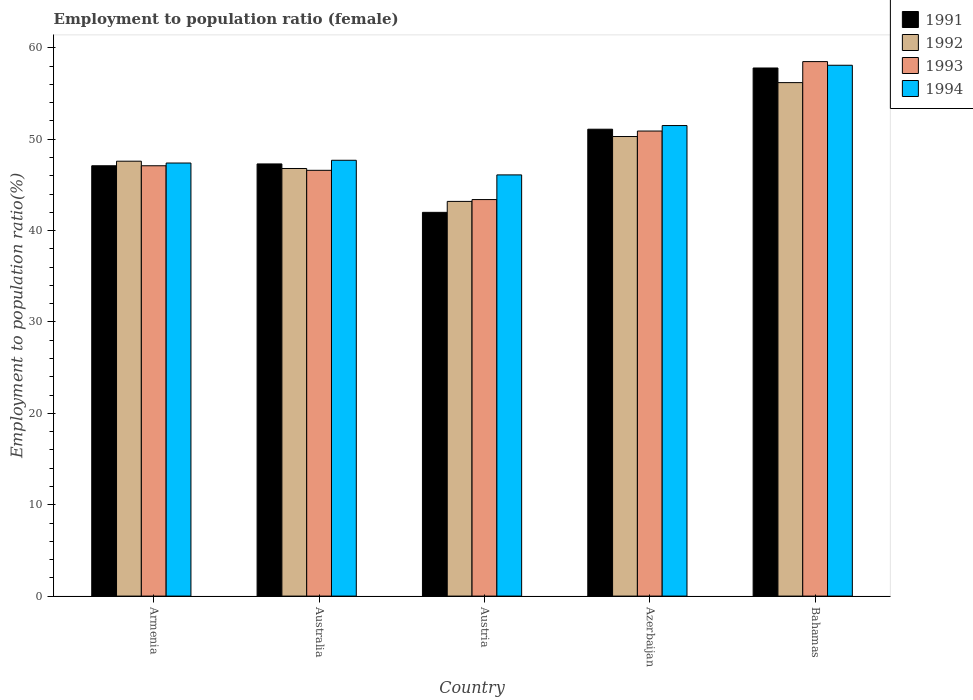How many groups of bars are there?
Provide a succinct answer. 5. How many bars are there on the 2nd tick from the left?
Your answer should be very brief. 4. How many bars are there on the 2nd tick from the right?
Offer a very short reply. 4. What is the label of the 2nd group of bars from the left?
Make the answer very short. Australia. What is the employment to population ratio in 1993 in Australia?
Give a very brief answer. 46.6. Across all countries, what is the maximum employment to population ratio in 1994?
Provide a succinct answer. 58.1. Across all countries, what is the minimum employment to population ratio in 1992?
Your response must be concise. 43.2. In which country was the employment to population ratio in 1992 maximum?
Make the answer very short. Bahamas. In which country was the employment to population ratio in 1994 minimum?
Give a very brief answer. Austria. What is the total employment to population ratio in 1994 in the graph?
Give a very brief answer. 250.8. What is the difference between the employment to population ratio in 1992 in Armenia and that in Azerbaijan?
Offer a terse response. -2.7. What is the difference between the employment to population ratio in 1991 in Armenia and the employment to population ratio in 1994 in Azerbaijan?
Give a very brief answer. -4.4. What is the average employment to population ratio in 1992 per country?
Keep it short and to the point. 48.82. What is the difference between the employment to population ratio of/in 1991 and employment to population ratio of/in 1994 in Azerbaijan?
Offer a terse response. -0.4. In how many countries, is the employment to population ratio in 1991 greater than 4 %?
Provide a short and direct response. 5. What is the ratio of the employment to population ratio in 1991 in Azerbaijan to that in Bahamas?
Provide a succinct answer. 0.88. Is the employment to population ratio in 1993 in Austria less than that in Azerbaijan?
Provide a succinct answer. Yes. Is the difference between the employment to population ratio in 1991 in Armenia and Austria greater than the difference between the employment to population ratio in 1994 in Armenia and Austria?
Offer a very short reply. Yes. What is the difference between the highest and the second highest employment to population ratio in 1993?
Offer a terse response. 7.6. What is the difference between the highest and the lowest employment to population ratio in 1992?
Your answer should be compact. 13. Is it the case that in every country, the sum of the employment to population ratio in 1992 and employment to population ratio in 1994 is greater than the sum of employment to population ratio in 1991 and employment to population ratio in 1993?
Offer a terse response. No. What does the 2nd bar from the left in Azerbaijan represents?
Provide a succinct answer. 1992. What does the 3rd bar from the right in Austria represents?
Your answer should be very brief. 1992. How many bars are there?
Your response must be concise. 20. Are all the bars in the graph horizontal?
Provide a succinct answer. No. How many countries are there in the graph?
Ensure brevity in your answer.  5. Does the graph contain grids?
Ensure brevity in your answer.  No. How many legend labels are there?
Ensure brevity in your answer.  4. How are the legend labels stacked?
Your answer should be compact. Vertical. What is the title of the graph?
Ensure brevity in your answer.  Employment to population ratio (female). Does "1969" appear as one of the legend labels in the graph?
Offer a terse response. No. What is the label or title of the Y-axis?
Your answer should be compact. Employment to population ratio(%). What is the Employment to population ratio(%) of 1991 in Armenia?
Your answer should be compact. 47.1. What is the Employment to population ratio(%) in 1992 in Armenia?
Give a very brief answer. 47.6. What is the Employment to population ratio(%) in 1993 in Armenia?
Make the answer very short. 47.1. What is the Employment to population ratio(%) in 1994 in Armenia?
Provide a succinct answer. 47.4. What is the Employment to population ratio(%) of 1991 in Australia?
Give a very brief answer. 47.3. What is the Employment to population ratio(%) of 1992 in Australia?
Your answer should be very brief. 46.8. What is the Employment to population ratio(%) of 1993 in Australia?
Make the answer very short. 46.6. What is the Employment to population ratio(%) of 1994 in Australia?
Ensure brevity in your answer.  47.7. What is the Employment to population ratio(%) in 1991 in Austria?
Provide a short and direct response. 42. What is the Employment to population ratio(%) of 1992 in Austria?
Offer a terse response. 43.2. What is the Employment to population ratio(%) in 1993 in Austria?
Offer a very short reply. 43.4. What is the Employment to population ratio(%) of 1994 in Austria?
Offer a terse response. 46.1. What is the Employment to population ratio(%) in 1991 in Azerbaijan?
Offer a very short reply. 51.1. What is the Employment to population ratio(%) of 1992 in Azerbaijan?
Keep it short and to the point. 50.3. What is the Employment to population ratio(%) of 1993 in Azerbaijan?
Ensure brevity in your answer.  50.9. What is the Employment to population ratio(%) in 1994 in Azerbaijan?
Your response must be concise. 51.5. What is the Employment to population ratio(%) in 1991 in Bahamas?
Offer a very short reply. 57.8. What is the Employment to population ratio(%) of 1992 in Bahamas?
Keep it short and to the point. 56.2. What is the Employment to population ratio(%) in 1993 in Bahamas?
Your response must be concise. 58.5. What is the Employment to population ratio(%) of 1994 in Bahamas?
Your response must be concise. 58.1. Across all countries, what is the maximum Employment to population ratio(%) of 1991?
Ensure brevity in your answer.  57.8. Across all countries, what is the maximum Employment to population ratio(%) in 1992?
Give a very brief answer. 56.2. Across all countries, what is the maximum Employment to population ratio(%) of 1993?
Your answer should be very brief. 58.5. Across all countries, what is the maximum Employment to population ratio(%) in 1994?
Your response must be concise. 58.1. Across all countries, what is the minimum Employment to population ratio(%) in 1991?
Your response must be concise. 42. Across all countries, what is the minimum Employment to population ratio(%) in 1992?
Offer a terse response. 43.2. Across all countries, what is the minimum Employment to population ratio(%) in 1993?
Offer a terse response. 43.4. Across all countries, what is the minimum Employment to population ratio(%) of 1994?
Make the answer very short. 46.1. What is the total Employment to population ratio(%) in 1991 in the graph?
Ensure brevity in your answer.  245.3. What is the total Employment to population ratio(%) in 1992 in the graph?
Your answer should be compact. 244.1. What is the total Employment to population ratio(%) of 1993 in the graph?
Your answer should be very brief. 246.5. What is the total Employment to population ratio(%) of 1994 in the graph?
Keep it short and to the point. 250.8. What is the difference between the Employment to population ratio(%) of 1991 in Armenia and that in Australia?
Your response must be concise. -0.2. What is the difference between the Employment to population ratio(%) in 1992 in Armenia and that in Australia?
Ensure brevity in your answer.  0.8. What is the difference between the Employment to population ratio(%) of 1993 in Armenia and that in Australia?
Ensure brevity in your answer.  0.5. What is the difference between the Employment to population ratio(%) of 1993 in Armenia and that in Austria?
Your response must be concise. 3.7. What is the difference between the Employment to population ratio(%) in 1994 in Armenia and that in Austria?
Offer a very short reply. 1.3. What is the difference between the Employment to population ratio(%) in 1993 in Armenia and that in Azerbaijan?
Provide a succinct answer. -3.8. What is the difference between the Employment to population ratio(%) in 1993 in Armenia and that in Bahamas?
Your response must be concise. -11.4. What is the difference between the Employment to population ratio(%) in 1992 in Australia and that in Austria?
Give a very brief answer. 3.6. What is the difference between the Employment to population ratio(%) in 1994 in Australia and that in Austria?
Provide a succinct answer. 1.6. What is the difference between the Employment to population ratio(%) of 1993 in Australia and that in Bahamas?
Make the answer very short. -11.9. What is the difference between the Employment to population ratio(%) in 1991 in Austria and that in Azerbaijan?
Provide a short and direct response. -9.1. What is the difference between the Employment to population ratio(%) in 1992 in Austria and that in Azerbaijan?
Provide a succinct answer. -7.1. What is the difference between the Employment to population ratio(%) of 1993 in Austria and that in Azerbaijan?
Make the answer very short. -7.5. What is the difference between the Employment to population ratio(%) of 1994 in Austria and that in Azerbaijan?
Keep it short and to the point. -5.4. What is the difference between the Employment to population ratio(%) in 1991 in Austria and that in Bahamas?
Provide a succinct answer. -15.8. What is the difference between the Employment to population ratio(%) in 1993 in Austria and that in Bahamas?
Your answer should be very brief. -15.1. What is the difference between the Employment to population ratio(%) in 1991 in Azerbaijan and that in Bahamas?
Offer a very short reply. -6.7. What is the difference between the Employment to population ratio(%) of 1993 in Azerbaijan and that in Bahamas?
Provide a succinct answer. -7.6. What is the difference between the Employment to population ratio(%) in 1994 in Azerbaijan and that in Bahamas?
Your answer should be compact. -6.6. What is the difference between the Employment to population ratio(%) in 1991 in Armenia and the Employment to population ratio(%) in 1993 in Australia?
Provide a succinct answer. 0.5. What is the difference between the Employment to population ratio(%) in 1991 in Armenia and the Employment to population ratio(%) in 1994 in Australia?
Your answer should be very brief. -0.6. What is the difference between the Employment to population ratio(%) of 1992 in Armenia and the Employment to population ratio(%) of 1994 in Australia?
Offer a terse response. -0.1. What is the difference between the Employment to population ratio(%) of 1993 in Armenia and the Employment to population ratio(%) of 1994 in Australia?
Offer a very short reply. -0.6. What is the difference between the Employment to population ratio(%) in 1991 in Armenia and the Employment to population ratio(%) in 1992 in Austria?
Your answer should be compact. 3.9. What is the difference between the Employment to population ratio(%) in 1991 in Armenia and the Employment to population ratio(%) in 1994 in Austria?
Offer a very short reply. 1. What is the difference between the Employment to population ratio(%) of 1991 in Armenia and the Employment to population ratio(%) of 1992 in Azerbaijan?
Your answer should be very brief. -3.2. What is the difference between the Employment to population ratio(%) of 1991 in Armenia and the Employment to population ratio(%) of 1993 in Azerbaijan?
Offer a terse response. -3.8. What is the difference between the Employment to population ratio(%) in 1993 in Armenia and the Employment to population ratio(%) in 1994 in Azerbaijan?
Offer a terse response. -4.4. What is the difference between the Employment to population ratio(%) in 1991 in Armenia and the Employment to population ratio(%) in 1992 in Bahamas?
Your answer should be very brief. -9.1. What is the difference between the Employment to population ratio(%) of 1991 in Armenia and the Employment to population ratio(%) of 1994 in Bahamas?
Offer a terse response. -11. What is the difference between the Employment to population ratio(%) of 1992 in Armenia and the Employment to population ratio(%) of 1993 in Bahamas?
Provide a succinct answer. -10.9. What is the difference between the Employment to population ratio(%) of 1992 in Armenia and the Employment to population ratio(%) of 1994 in Bahamas?
Provide a short and direct response. -10.5. What is the difference between the Employment to population ratio(%) in 1991 in Australia and the Employment to population ratio(%) in 1992 in Austria?
Provide a succinct answer. 4.1. What is the difference between the Employment to population ratio(%) in 1993 in Australia and the Employment to population ratio(%) in 1994 in Austria?
Ensure brevity in your answer.  0.5. What is the difference between the Employment to population ratio(%) in 1991 in Australia and the Employment to population ratio(%) in 1992 in Azerbaijan?
Your answer should be very brief. -3. What is the difference between the Employment to population ratio(%) of 1991 in Australia and the Employment to population ratio(%) of 1992 in Bahamas?
Keep it short and to the point. -8.9. What is the difference between the Employment to population ratio(%) of 1991 in Australia and the Employment to population ratio(%) of 1993 in Bahamas?
Your answer should be compact. -11.2. What is the difference between the Employment to population ratio(%) of 1991 in Australia and the Employment to population ratio(%) of 1994 in Bahamas?
Give a very brief answer. -10.8. What is the difference between the Employment to population ratio(%) of 1993 in Australia and the Employment to population ratio(%) of 1994 in Bahamas?
Offer a very short reply. -11.5. What is the difference between the Employment to population ratio(%) in 1991 in Austria and the Employment to population ratio(%) in 1992 in Azerbaijan?
Your response must be concise. -8.3. What is the difference between the Employment to population ratio(%) in 1991 in Austria and the Employment to population ratio(%) in 1994 in Azerbaijan?
Make the answer very short. -9.5. What is the difference between the Employment to population ratio(%) of 1992 in Austria and the Employment to population ratio(%) of 1994 in Azerbaijan?
Make the answer very short. -8.3. What is the difference between the Employment to population ratio(%) of 1993 in Austria and the Employment to population ratio(%) of 1994 in Azerbaijan?
Provide a short and direct response. -8.1. What is the difference between the Employment to population ratio(%) of 1991 in Austria and the Employment to population ratio(%) of 1993 in Bahamas?
Your response must be concise. -16.5. What is the difference between the Employment to population ratio(%) in 1991 in Austria and the Employment to population ratio(%) in 1994 in Bahamas?
Your answer should be compact. -16.1. What is the difference between the Employment to population ratio(%) in 1992 in Austria and the Employment to population ratio(%) in 1993 in Bahamas?
Provide a succinct answer. -15.3. What is the difference between the Employment to population ratio(%) of 1992 in Austria and the Employment to population ratio(%) of 1994 in Bahamas?
Offer a very short reply. -14.9. What is the difference between the Employment to population ratio(%) of 1993 in Austria and the Employment to population ratio(%) of 1994 in Bahamas?
Provide a succinct answer. -14.7. What is the difference between the Employment to population ratio(%) of 1991 in Azerbaijan and the Employment to population ratio(%) of 1992 in Bahamas?
Keep it short and to the point. -5.1. What is the difference between the Employment to population ratio(%) of 1992 in Azerbaijan and the Employment to population ratio(%) of 1994 in Bahamas?
Your response must be concise. -7.8. What is the difference between the Employment to population ratio(%) of 1993 in Azerbaijan and the Employment to population ratio(%) of 1994 in Bahamas?
Your answer should be compact. -7.2. What is the average Employment to population ratio(%) in 1991 per country?
Give a very brief answer. 49.06. What is the average Employment to population ratio(%) of 1992 per country?
Your response must be concise. 48.82. What is the average Employment to population ratio(%) of 1993 per country?
Ensure brevity in your answer.  49.3. What is the average Employment to population ratio(%) of 1994 per country?
Provide a short and direct response. 50.16. What is the difference between the Employment to population ratio(%) of 1991 and Employment to population ratio(%) of 1993 in Armenia?
Give a very brief answer. 0. What is the difference between the Employment to population ratio(%) of 1991 and Employment to population ratio(%) of 1993 in Australia?
Provide a short and direct response. 0.7. What is the difference between the Employment to population ratio(%) in 1992 and Employment to population ratio(%) in 1993 in Austria?
Give a very brief answer. -0.2. What is the difference between the Employment to population ratio(%) of 1991 and Employment to population ratio(%) of 1992 in Azerbaijan?
Offer a terse response. 0.8. What is the difference between the Employment to population ratio(%) of 1991 and Employment to population ratio(%) of 1993 in Azerbaijan?
Offer a terse response. 0.2. What is the difference between the Employment to population ratio(%) in 1992 and Employment to population ratio(%) in 1994 in Azerbaijan?
Your response must be concise. -1.2. What is the difference between the Employment to population ratio(%) of 1991 and Employment to population ratio(%) of 1993 in Bahamas?
Your answer should be very brief. -0.7. What is the difference between the Employment to population ratio(%) of 1992 and Employment to population ratio(%) of 1994 in Bahamas?
Offer a terse response. -1.9. What is the difference between the Employment to population ratio(%) in 1993 and Employment to population ratio(%) in 1994 in Bahamas?
Offer a very short reply. 0.4. What is the ratio of the Employment to population ratio(%) in 1991 in Armenia to that in Australia?
Make the answer very short. 1. What is the ratio of the Employment to population ratio(%) of 1992 in Armenia to that in Australia?
Provide a succinct answer. 1.02. What is the ratio of the Employment to population ratio(%) in 1993 in Armenia to that in Australia?
Provide a succinct answer. 1.01. What is the ratio of the Employment to population ratio(%) in 1991 in Armenia to that in Austria?
Keep it short and to the point. 1.12. What is the ratio of the Employment to population ratio(%) of 1992 in Armenia to that in Austria?
Make the answer very short. 1.1. What is the ratio of the Employment to population ratio(%) in 1993 in Armenia to that in Austria?
Offer a terse response. 1.09. What is the ratio of the Employment to population ratio(%) in 1994 in Armenia to that in Austria?
Your response must be concise. 1.03. What is the ratio of the Employment to population ratio(%) in 1991 in Armenia to that in Azerbaijan?
Offer a very short reply. 0.92. What is the ratio of the Employment to population ratio(%) of 1992 in Armenia to that in Azerbaijan?
Your response must be concise. 0.95. What is the ratio of the Employment to population ratio(%) of 1993 in Armenia to that in Azerbaijan?
Your answer should be very brief. 0.93. What is the ratio of the Employment to population ratio(%) in 1994 in Armenia to that in Azerbaijan?
Provide a short and direct response. 0.92. What is the ratio of the Employment to population ratio(%) in 1991 in Armenia to that in Bahamas?
Offer a very short reply. 0.81. What is the ratio of the Employment to population ratio(%) of 1992 in Armenia to that in Bahamas?
Make the answer very short. 0.85. What is the ratio of the Employment to population ratio(%) of 1993 in Armenia to that in Bahamas?
Your answer should be very brief. 0.81. What is the ratio of the Employment to population ratio(%) in 1994 in Armenia to that in Bahamas?
Give a very brief answer. 0.82. What is the ratio of the Employment to population ratio(%) in 1991 in Australia to that in Austria?
Your answer should be compact. 1.13. What is the ratio of the Employment to population ratio(%) in 1993 in Australia to that in Austria?
Provide a succinct answer. 1.07. What is the ratio of the Employment to population ratio(%) in 1994 in Australia to that in Austria?
Your response must be concise. 1.03. What is the ratio of the Employment to population ratio(%) of 1991 in Australia to that in Azerbaijan?
Ensure brevity in your answer.  0.93. What is the ratio of the Employment to population ratio(%) of 1992 in Australia to that in Azerbaijan?
Offer a very short reply. 0.93. What is the ratio of the Employment to population ratio(%) of 1993 in Australia to that in Azerbaijan?
Ensure brevity in your answer.  0.92. What is the ratio of the Employment to population ratio(%) of 1994 in Australia to that in Azerbaijan?
Ensure brevity in your answer.  0.93. What is the ratio of the Employment to population ratio(%) in 1991 in Australia to that in Bahamas?
Your answer should be compact. 0.82. What is the ratio of the Employment to population ratio(%) of 1992 in Australia to that in Bahamas?
Provide a short and direct response. 0.83. What is the ratio of the Employment to population ratio(%) in 1993 in Australia to that in Bahamas?
Give a very brief answer. 0.8. What is the ratio of the Employment to population ratio(%) in 1994 in Australia to that in Bahamas?
Your answer should be very brief. 0.82. What is the ratio of the Employment to population ratio(%) of 1991 in Austria to that in Azerbaijan?
Make the answer very short. 0.82. What is the ratio of the Employment to population ratio(%) of 1992 in Austria to that in Azerbaijan?
Give a very brief answer. 0.86. What is the ratio of the Employment to population ratio(%) of 1993 in Austria to that in Azerbaijan?
Your answer should be very brief. 0.85. What is the ratio of the Employment to population ratio(%) in 1994 in Austria to that in Azerbaijan?
Ensure brevity in your answer.  0.9. What is the ratio of the Employment to population ratio(%) of 1991 in Austria to that in Bahamas?
Your answer should be compact. 0.73. What is the ratio of the Employment to population ratio(%) in 1992 in Austria to that in Bahamas?
Give a very brief answer. 0.77. What is the ratio of the Employment to population ratio(%) in 1993 in Austria to that in Bahamas?
Provide a succinct answer. 0.74. What is the ratio of the Employment to population ratio(%) in 1994 in Austria to that in Bahamas?
Provide a succinct answer. 0.79. What is the ratio of the Employment to population ratio(%) of 1991 in Azerbaijan to that in Bahamas?
Offer a terse response. 0.88. What is the ratio of the Employment to population ratio(%) in 1992 in Azerbaijan to that in Bahamas?
Ensure brevity in your answer.  0.9. What is the ratio of the Employment to population ratio(%) of 1993 in Azerbaijan to that in Bahamas?
Your response must be concise. 0.87. What is the ratio of the Employment to population ratio(%) in 1994 in Azerbaijan to that in Bahamas?
Provide a short and direct response. 0.89. What is the difference between the highest and the second highest Employment to population ratio(%) in 1991?
Offer a terse response. 6.7. What is the difference between the highest and the second highest Employment to population ratio(%) of 1992?
Ensure brevity in your answer.  5.9. What is the difference between the highest and the second highest Employment to population ratio(%) of 1994?
Your answer should be very brief. 6.6. What is the difference between the highest and the lowest Employment to population ratio(%) in 1991?
Your answer should be compact. 15.8. What is the difference between the highest and the lowest Employment to population ratio(%) in 1994?
Provide a succinct answer. 12. 